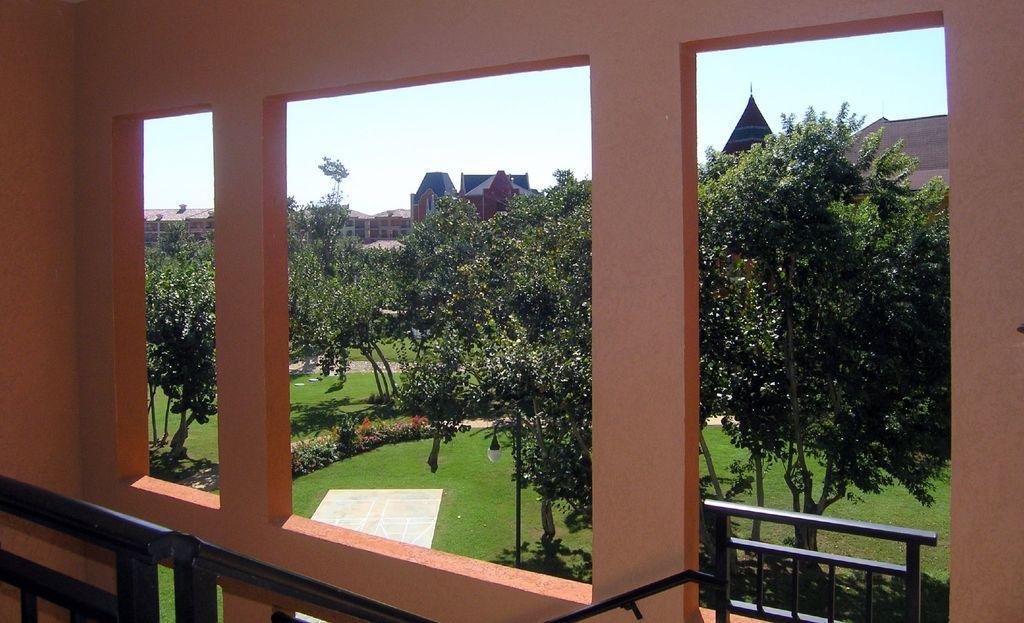Please provide a concise description of this image. In the foreground, I can see few pillars. At the bottom there is a railing. In the background there are many trees and buildings. On the ground, I can see the grass and plants. At the top of the image I can see the sky. 